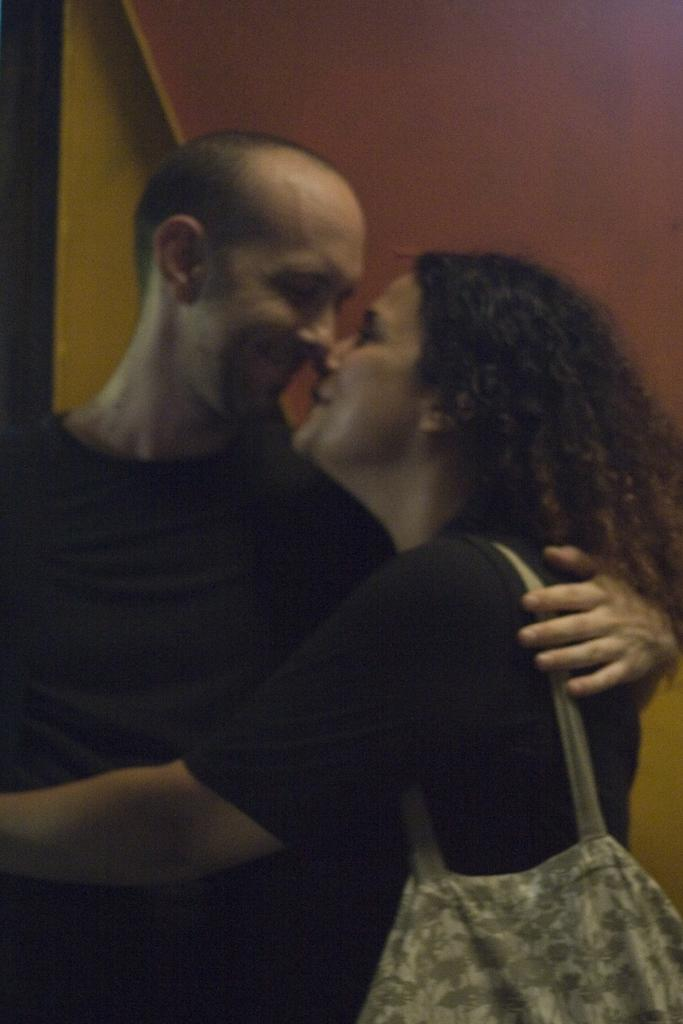How many people are in the image? There are two persons in the image. What are the expressions on their faces? Both persons are smiling. What color are the clothes they are wearing? Both persons are wearing black color dress. Is one of the persons carrying anything? Yes, one of the persons is carrying a bag. What type of wine is the boy drinking in the image? There is no boy or wine present in the image. Is the quicksand visible in the image? There is no quicksand present in the image. 